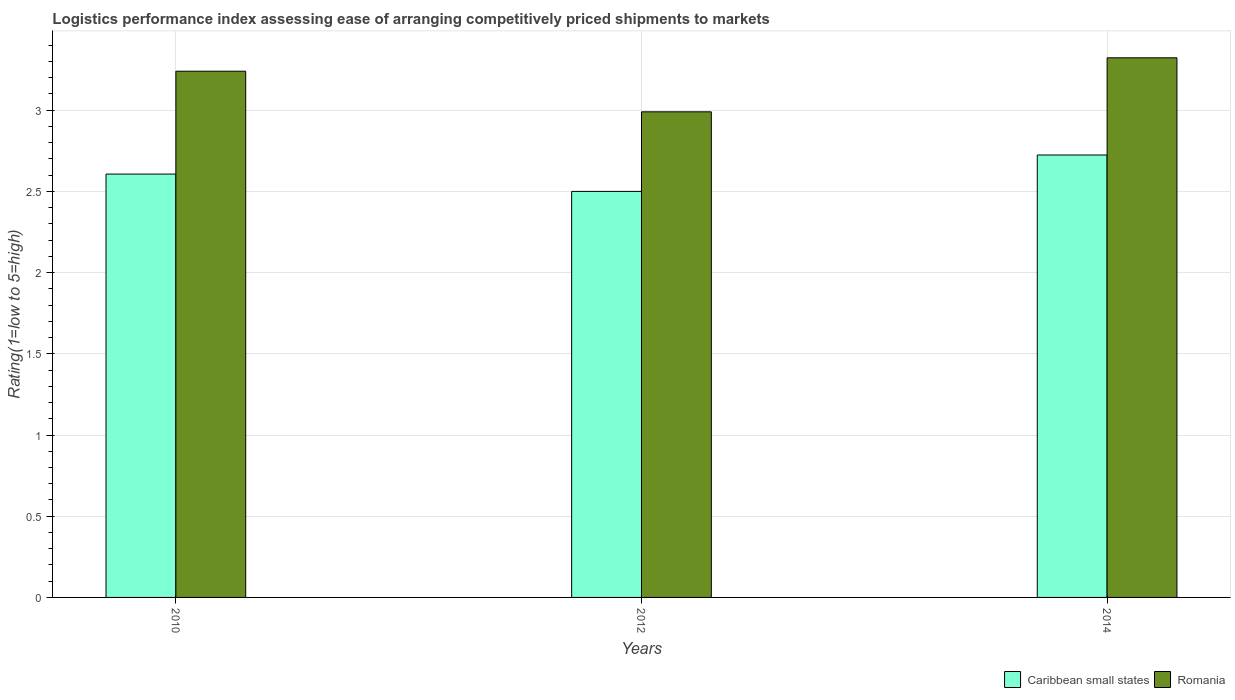How many groups of bars are there?
Your answer should be very brief. 3. Are the number of bars per tick equal to the number of legend labels?
Keep it short and to the point. Yes. How many bars are there on the 3rd tick from the right?
Give a very brief answer. 2. What is the Logistic performance index in Caribbean small states in 2014?
Provide a short and direct response. 2.72. Across all years, what is the maximum Logistic performance index in Romania?
Offer a very short reply. 3.32. Across all years, what is the minimum Logistic performance index in Caribbean small states?
Offer a very short reply. 2.5. What is the total Logistic performance index in Romania in the graph?
Your response must be concise. 9.55. What is the difference between the Logistic performance index in Caribbean small states in 2010 and the Logistic performance index in Romania in 2012?
Offer a very short reply. -0.38. What is the average Logistic performance index in Caribbean small states per year?
Offer a terse response. 2.61. In the year 2010, what is the difference between the Logistic performance index in Romania and Logistic performance index in Caribbean small states?
Provide a succinct answer. 0.63. In how many years, is the Logistic performance index in Romania greater than 3?
Provide a short and direct response. 2. What is the ratio of the Logistic performance index in Caribbean small states in 2010 to that in 2014?
Offer a very short reply. 0.96. Is the difference between the Logistic performance index in Romania in 2010 and 2012 greater than the difference between the Logistic performance index in Caribbean small states in 2010 and 2012?
Your response must be concise. Yes. What is the difference between the highest and the second highest Logistic performance index in Caribbean small states?
Offer a very short reply. 0.12. What is the difference between the highest and the lowest Logistic performance index in Caribbean small states?
Provide a succinct answer. 0.22. What does the 2nd bar from the left in 2014 represents?
Ensure brevity in your answer.  Romania. What does the 1st bar from the right in 2014 represents?
Give a very brief answer. Romania. How many bars are there?
Your answer should be compact. 6. Are all the bars in the graph horizontal?
Provide a succinct answer. No. How many years are there in the graph?
Your answer should be compact. 3. Does the graph contain any zero values?
Offer a very short reply. No. What is the title of the graph?
Give a very brief answer. Logistics performance index assessing ease of arranging competitively priced shipments to markets. What is the label or title of the X-axis?
Give a very brief answer. Years. What is the label or title of the Y-axis?
Keep it short and to the point. Rating(1=low to 5=high). What is the Rating(1=low to 5=high) of Caribbean small states in 2010?
Your response must be concise. 2.61. What is the Rating(1=low to 5=high) in Romania in 2010?
Keep it short and to the point. 3.24. What is the Rating(1=low to 5=high) of Romania in 2012?
Your response must be concise. 2.99. What is the Rating(1=low to 5=high) of Caribbean small states in 2014?
Provide a short and direct response. 2.72. What is the Rating(1=low to 5=high) of Romania in 2014?
Keep it short and to the point. 3.32. Across all years, what is the maximum Rating(1=low to 5=high) in Caribbean small states?
Your answer should be very brief. 2.72. Across all years, what is the maximum Rating(1=low to 5=high) in Romania?
Your answer should be very brief. 3.32. Across all years, what is the minimum Rating(1=low to 5=high) in Caribbean small states?
Provide a short and direct response. 2.5. Across all years, what is the minimum Rating(1=low to 5=high) in Romania?
Your answer should be compact. 2.99. What is the total Rating(1=low to 5=high) in Caribbean small states in the graph?
Your answer should be very brief. 7.83. What is the total Rating(1=low to 5=high) of Romania in the graph?
Offer a terse response. 9.55. What is the difference between the Rating(1=low to 5=high) of Caribbean small states in 2010 and that in 2012?
Your answer should be compact. 0.11. What is the difference between the Rating(1=low to 5=high) of Romania in 2010 and that in 2012?
Ensure brevity in your answer.  0.25. What is the difference between the Rating(1=low to 5=high) in Caribbean small states in 2010 and that in 2014?
Provide a short and direct response. -0.12. What is the difference between the Rating(1=low to 5=high) in Romania in 2010 and that in 2014?
Your answer should be very brief. -0.08. What is the difference between the Rating(1=low to 5=high) of Caribbean small states in 2012 and that in 2014?
Your answer should be very brief. -0.22. What is the difference between the Rating(1=low to 5=high) in Romania in 2012 and that in 2014?
Your answer should be compact. -0.33. What is the difference between the Rating(1=low to 5=high) in Caribbean small states in 2010 and the Rating(1=low to 5=high) in Romania in 2012?
Provide a short and direct response. -0.38. What is the difference between the Rating(1=low to 5=high) in Caribbean small states in 2010 and the Rating(1=low to 5=high) in Romania in 2014?
Provide a short and direct response. -0.72. What is the difference between the Rating(1=low to 5=high) of Caribbean small states in 2012 and the Rating(1=low to 5=high) of Romania in 2014?
Provide a short and direct response. -0.82. What is the average Rating(1=low to 5=high) of Caribbean small states per year?
Give a very brief answer. 2.61. What is the average Rating(1=low to 5=high) of Romania per year?
Keep it short and to the point. 3.18. In the year 2010, what is the difference between the Rating(1=low to 5=high) in Caribbean small states and Rating(1=low to 5=high) in Romania?
Ensure brevity in your answer.  -0.63. In the year 2012, what is the difference between the Rating(1=low to 5=high) in Caribbean small states and Rating(1=low to 5=high) in Romania?
Give a very brief answer. -0.49. In the year 2014, what is the difference between the Rating(1=low to 5=high) in Caribbean small states and Rating(1=low to 5=high) in Romania?
Your response must be concise. -0.6. What is the ratio of the Rating(1=low to 5=high) of Caribbean small states in 2010 to that in 2012?
Your response must be concise. 1.04. What is the ratio of the Rating(1=low to 5=high) in Romania in 2010 to that in 2012?
Ensure brevity in your answer.  1.08. What is the ratio of the Rating(1=low to 5=high) in Caribbean small states in 2010 to that in 2014?
Ensure brevity in your answer.  0.96. What is the ratio of the Rating(1=low to 5=high) in Romania in 2010 to that in 2014?
Ensure brevity in your answer.  0.98. What is the ratio of the Rating(1=low to 5=high) of Caribbean small states in 2012 to that in 2014?
Give a very brief answer. 0.92. What is the ratio of the Rating(1=low to 5=high) of Romania in 2012 to that in 2014?
Offer a terse response. 0.9. What is the difference between the highest and the second highest Rating(1=low to 5=high) in Caribbean small states?
Offer a very short reply. 0.12. What is the difference between the highest and the second highest Rating(1=low to 5=high) of Romania?
Your response must be concise. 0.08. What is the difference between the highest and the lowest Rating(1=low to 5=high) in Caribbean small states?
Your answer should be compact. 0.22. What is the difference between the highest and the lowest Rating(1=low to 5=high) of Romania?
Give a very brief answer. 0.33. 